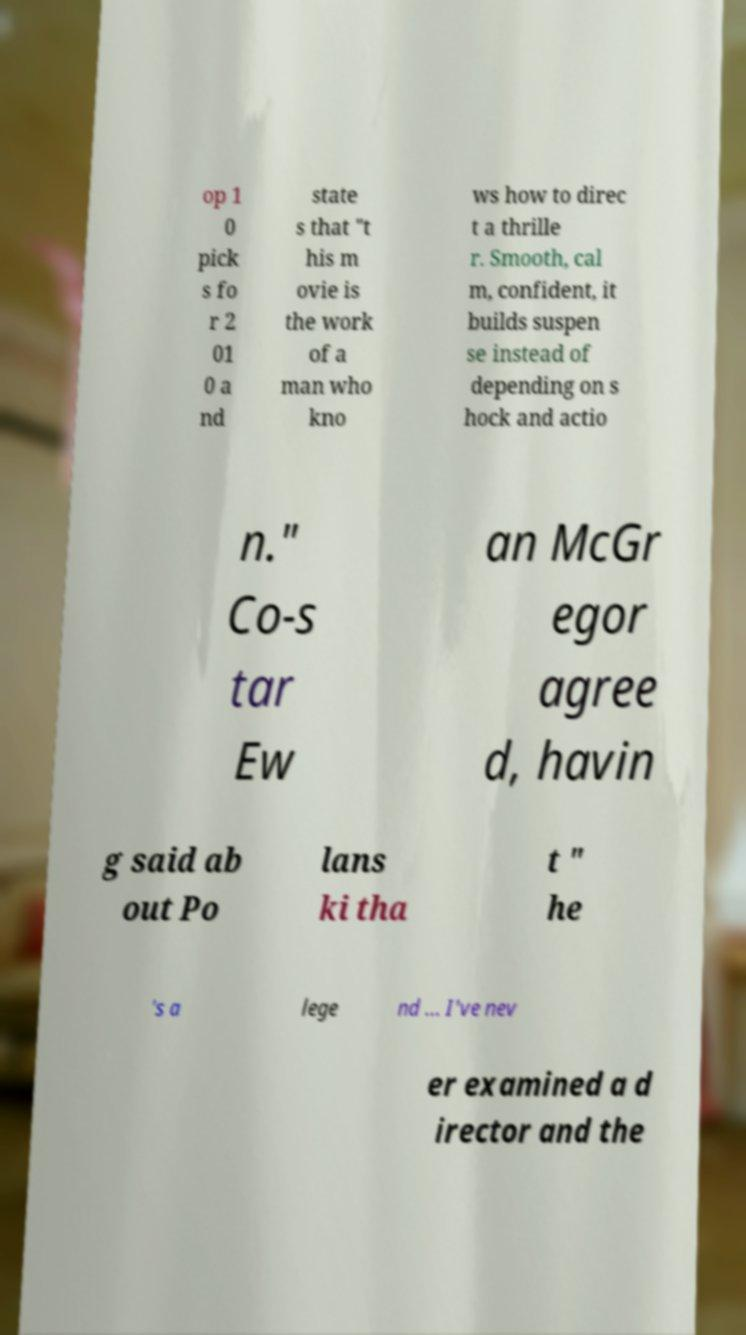I need the written content from this picture converted into text. Can you do that? op 1 0 pick s fo r 2 01 0 a nd state s that "t his m ovie is the work of a man who kno ws how to direc t a thrille r. Smooth, cal m, confident, it builds suspen se instead of depending on s hock and actio n." Co-s tar Ew an McGr egor agree d, havin g said ab out Po lans ki tha t " he 's a lege nd ... I've nev er examined a d irector and the 